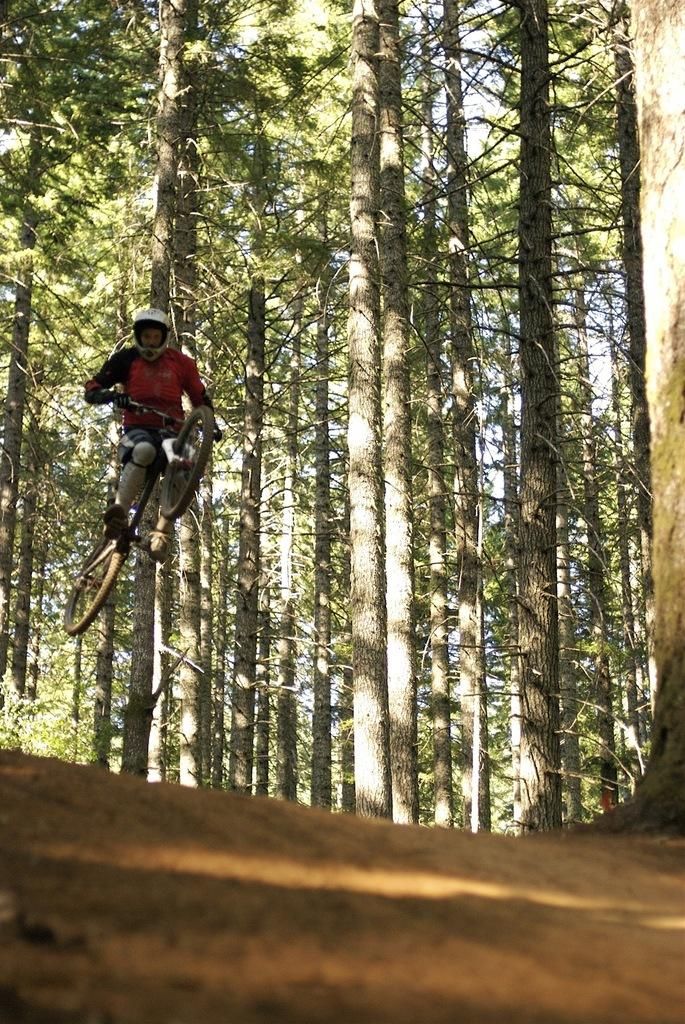What is happening in the image involving a person? The person is jumping with a bicycle in the air. What can be seen in the background of the image? There are trees visible in the image. How are the trees distributed in the image? The trees are spread across the land. How many icicles are hanging from the person's bicycle in the image? There are no icicles present in the image; the person is jumping with a bicycle in the air. What type of notebook is the person holding while jumping with the bicycle? There is no notebook present in the image; the person is focused on jumping with the bicycle. 